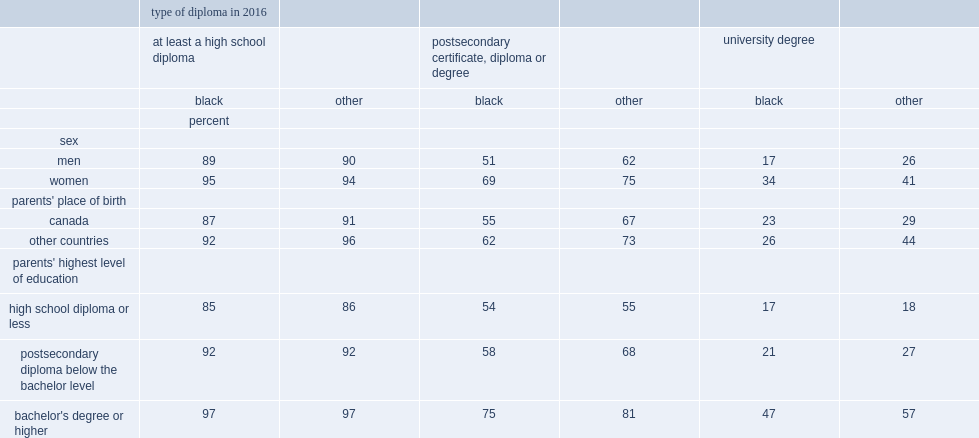What were the percentages of black women and black men who had a university degree rspectively? 34.0 17.0. Among other youth,what was the multiple relationship between women and men who had a university degree? 1.576923. Among youth who had at least one parent with a university degree (bachelor's degree or higher),what were the percentages of black youth and other youth who also held such a degree respectively? 47.0 57.0. Who were more likely to have a university degree,other youth with other-countries-born parents or other youth with canadian-born parents. Other countries. 